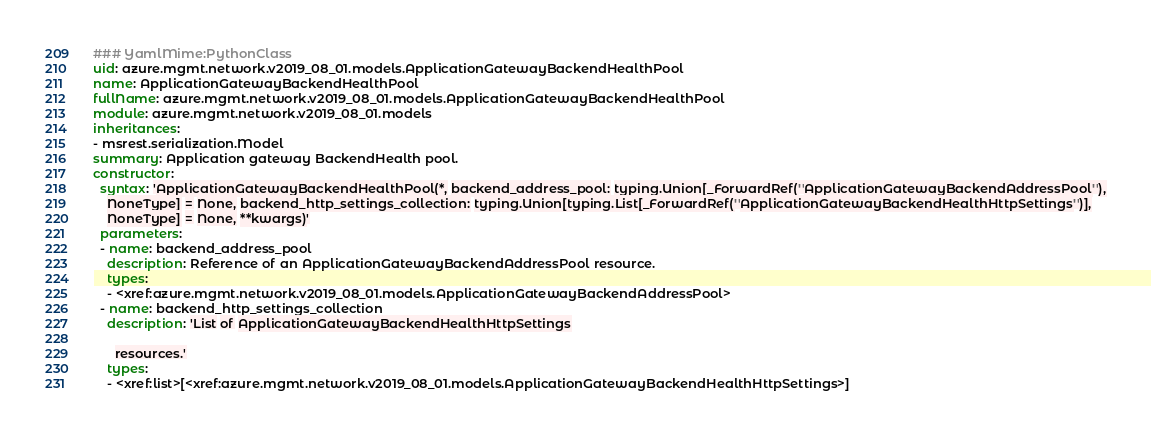Convert code to text. <code><loc_0><loc_0><loc_500><loc_500><_YAML_>### YamlMime:PythonClass
uid: azure.mgmt.network.v2019_08_01.models.ApplicationGatewayBackendHealthPool
name: ApplicationGatewayBackendHealthPool
fullName: azure.mgmt.network.v2019_08_01.models.ApplicationGatewayBackendHealthPool
module: azure.mgmt.network.v2019_08_01.models
inheritances:
- msrest.serialization.Model
summary: Application gateway BackendHealth pool.
constructor:
  syntax: 'ApplicationGatewayBackendHealthPool(*, backend_address_pool: typing.Union[_ForwardRef(''ApplicationGatewayBackendAddressPool''),
    NoneType] = None, backend_http_settings_collection: typing.Union[typing.List[_ForwardRef(''ApplicationGatewayBackendHealthHttpSettings'')],
    NoneType] = None, **kwargs)'
  parameters:
  - name: backend_address_pool
    description: Reference of an ApplicationGatewayBackendAddressPool resource.
    types:
    - <xref:azure.mgmt.network.v2019_08_01.models.ApplicationGatewayBackendAddressPool>
  - name: backend_http_settings_collection
    description: 'List of ApplicationGatewayBackendHealthHttpSettings

      resources.'
    types:
    - <xref:list>[<xref:azure.mgmt.network.v2019_08_01.models.ApplicationGatewayBackendHealthHttpSettings>]
</code> 